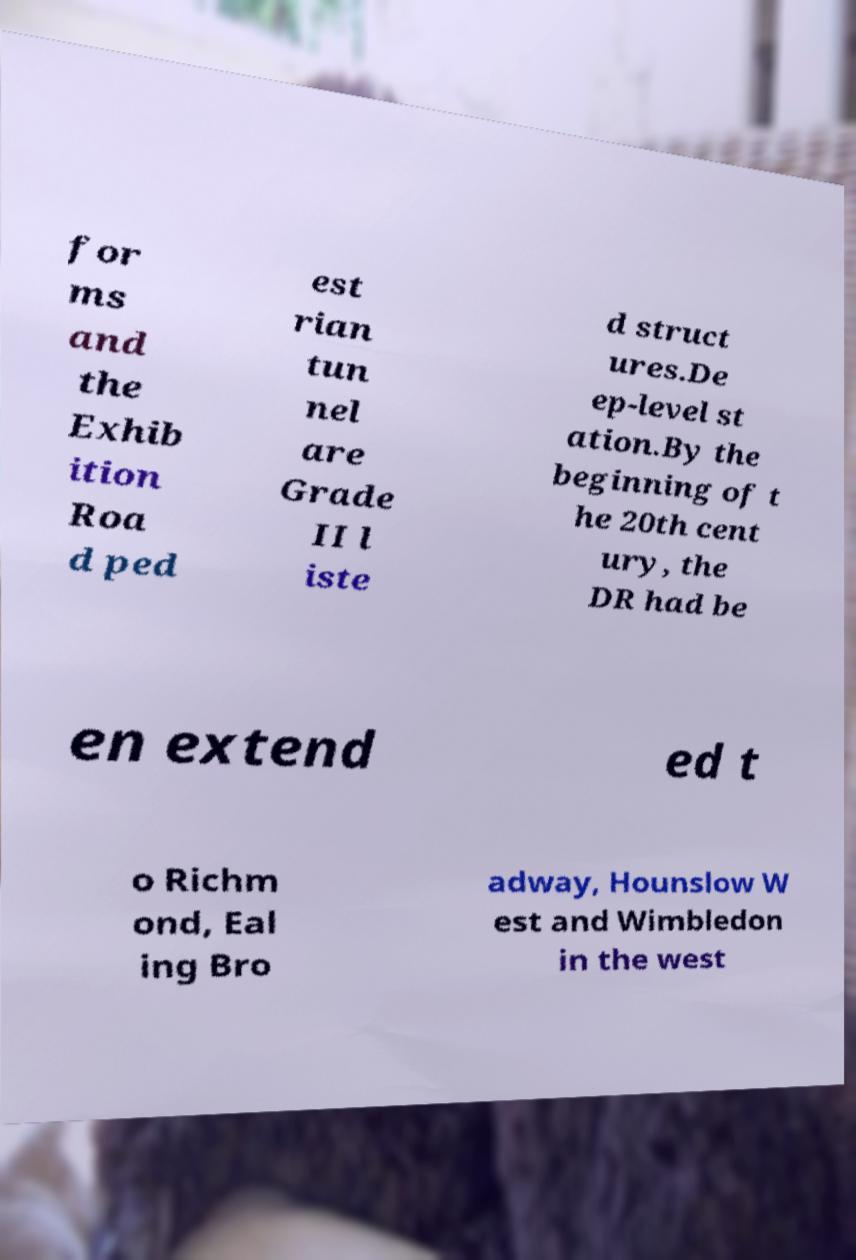What messages or text are displayed in this image? I need them in a readable, typed format. for ms and the Exhib ition Roa d ped est rian tun nel are Grade II l iste d struct ures.De ep-level st ation.By the beginning of t he 20th cent ury, the DR had be en extend ed t o Richm ond, Eal ing Bro adway, Hounslow W est and Wimbledon in the west 